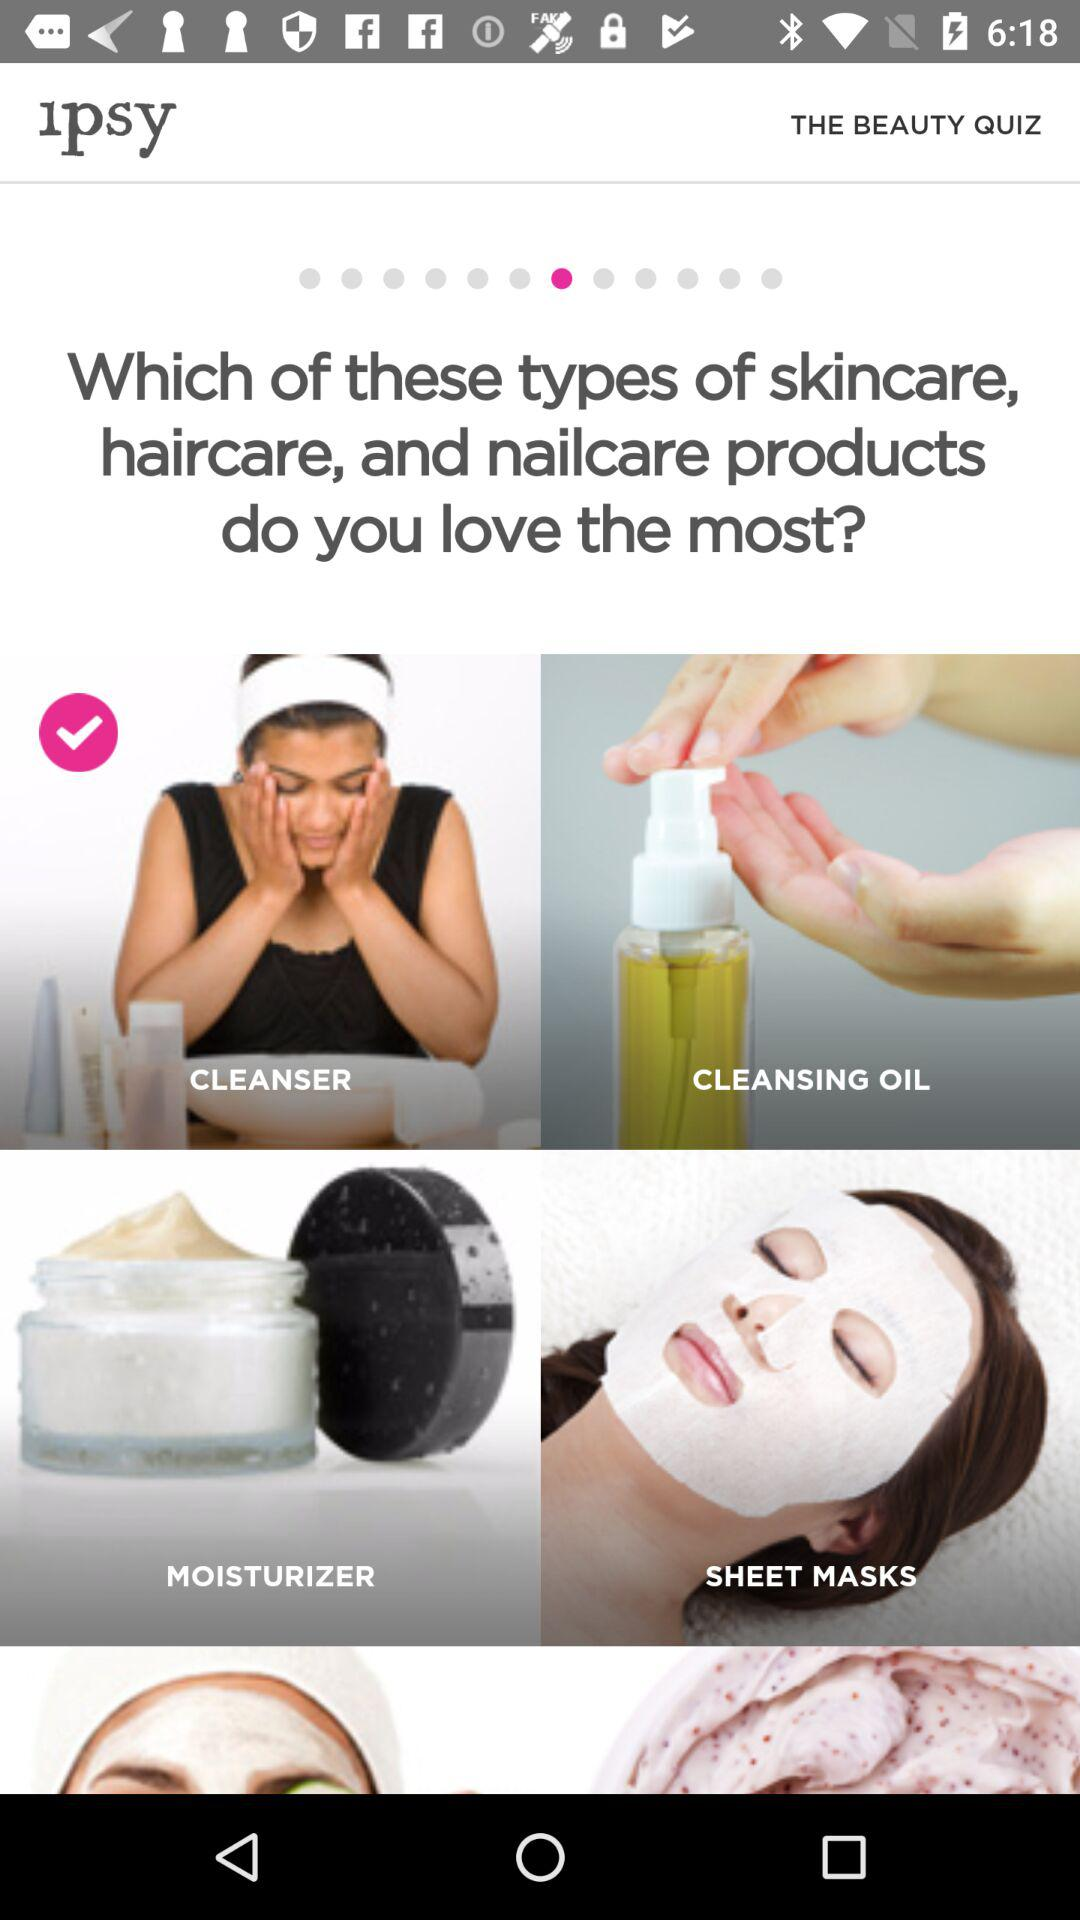What is the application Name? The application name is "IPSY". 